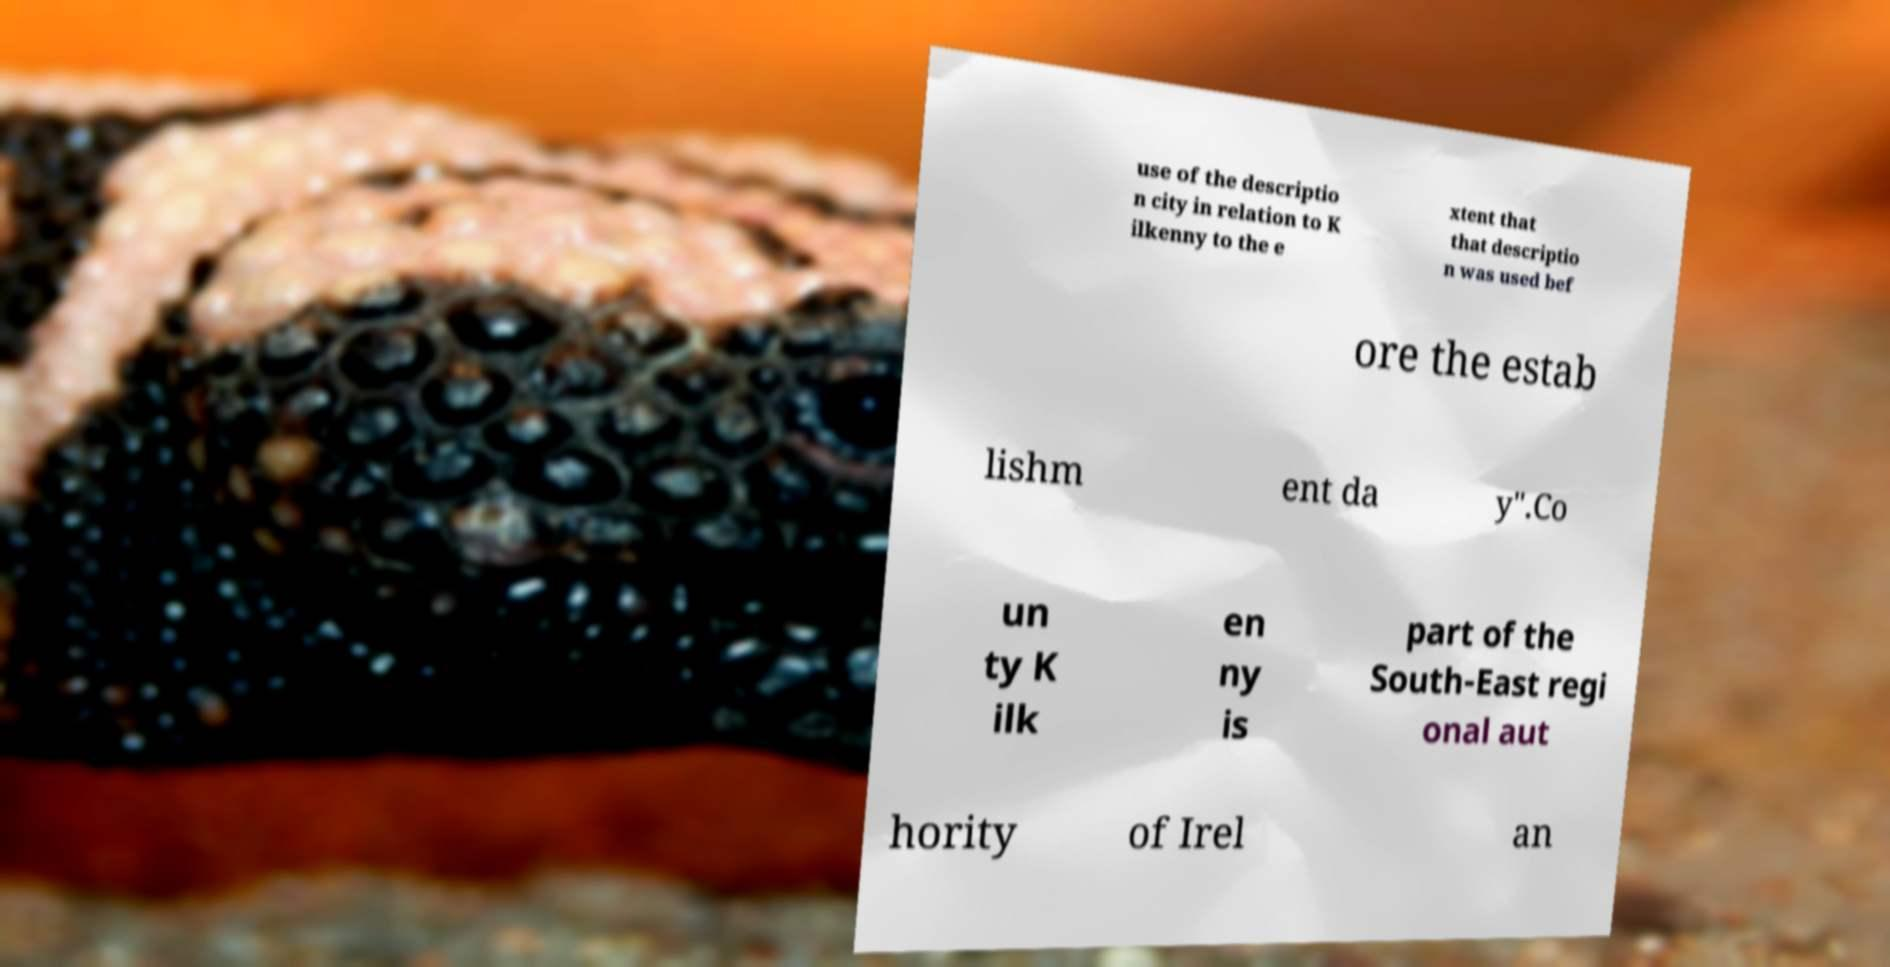For documentation purposes, I need the text within this image transcribed. Could you provide that? use of the descriptio n city in relation to K ilkenny to the e xtent that that descriptio n was used bef ore the estab lishm ent da y".Co un ty K ilk en ny is part of the South-East regi onal aut hority of Irel an 